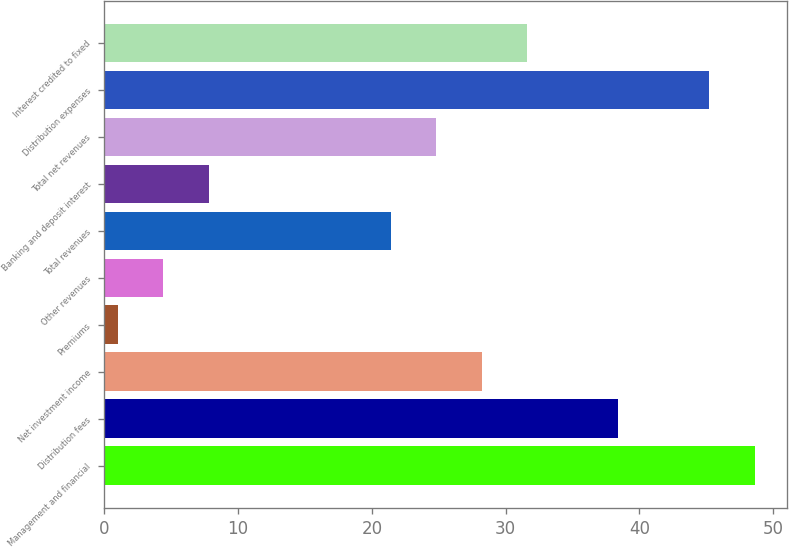<chart> <loc_0><loc_0><loc_500><loc_500><bar_chart><fcel>Management and financial<fcel>Distribution fees<fcel>Net investment income<fcel>Premiums<fcel>Other revenues<fcel>Total revenues<fcel>Banking and deposit interest<fcel>Total net revenues<fcel>Distribution expenses<fcel>Interest credited to fixed<nl><fcel>48.6<fcel>38.4<fcel>28.2<fcel>1<fcel>4.4<fcel>21.4<fcel>7.8<fcel>24.8<fcel>45.2<fcel>31.6<nl></chart> 